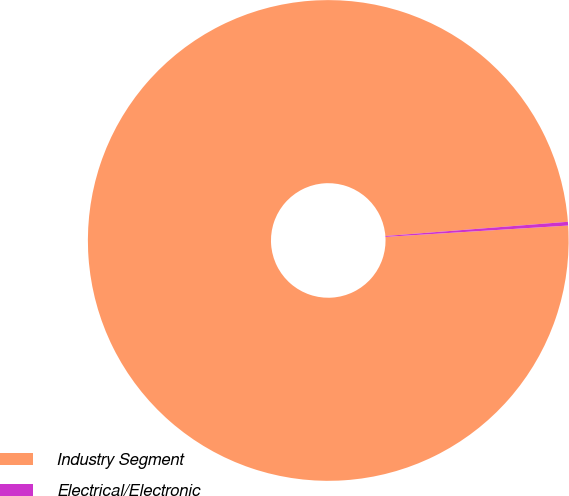Convert chart. <chart><loc_0><loc_0><loc_500><loc_500><pie_chart><fcel>Industry Segment<fcel>Electrical/Electronic<nl><fcel>99.75%<fcel>0.25%<nl></chart> 